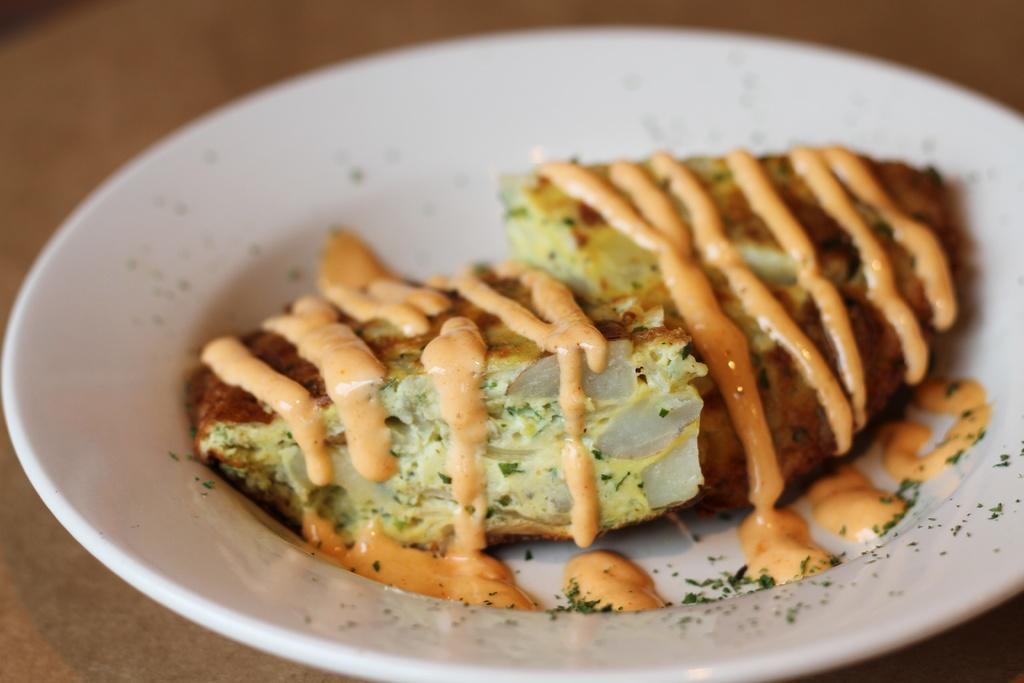Can you describe this image briefly? Here there is a food item in the white color plate. 